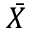Convert formula to latex. <formula><loc_0><loc_0><loc_500><loc_500>\bar { X }</formula> 